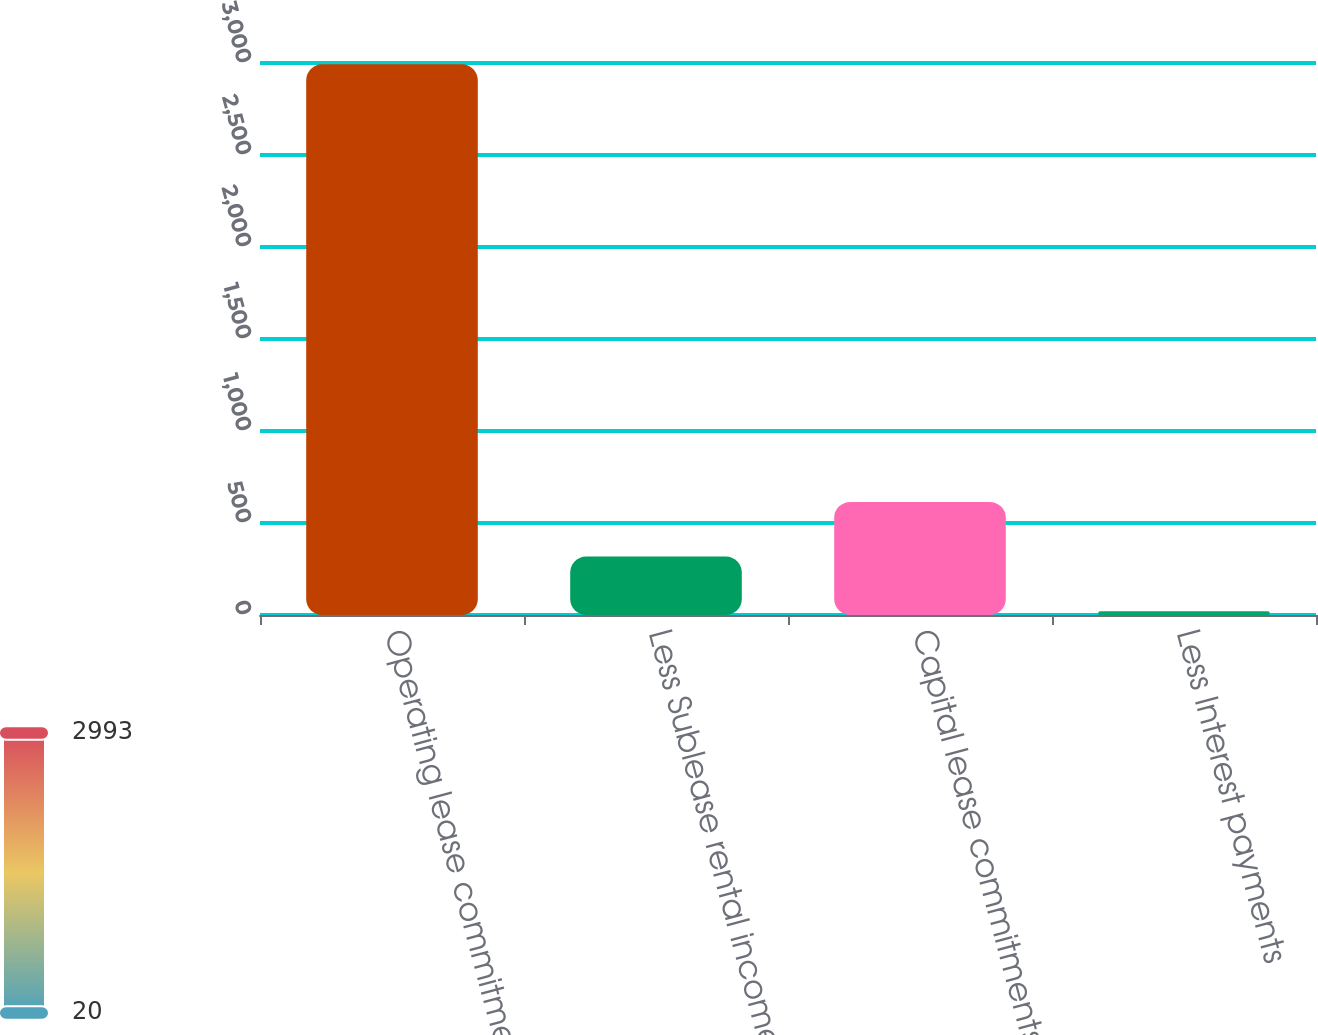Convert chart to OTSL. <chart><loc_0><loc_0><loc_500><loc_500><bar_chart><fcel>Operating lease commitments<fcel>Less Sublease rental income<fcel>Capital lease commitments<fcel>Less Interest payments<nl><fcel>2993<fcel>317.3<fcel>614.6<fcel>20<nl></chart> 